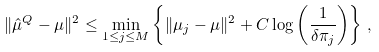<formula> <loc_0><loc_0><loc_500><loc_500>\| \hat { \mu } ^ { Q } - \mu \| ^ { 2 } \leq \min _ { 1 \leq j \leq M } \left \{ \| \mu _ { j } - \mu \| ^ { 2 } + C \log \left ( \frac { 1 } { \delta \pi _ { j } } \right ) \right \} \, ,</formula> 